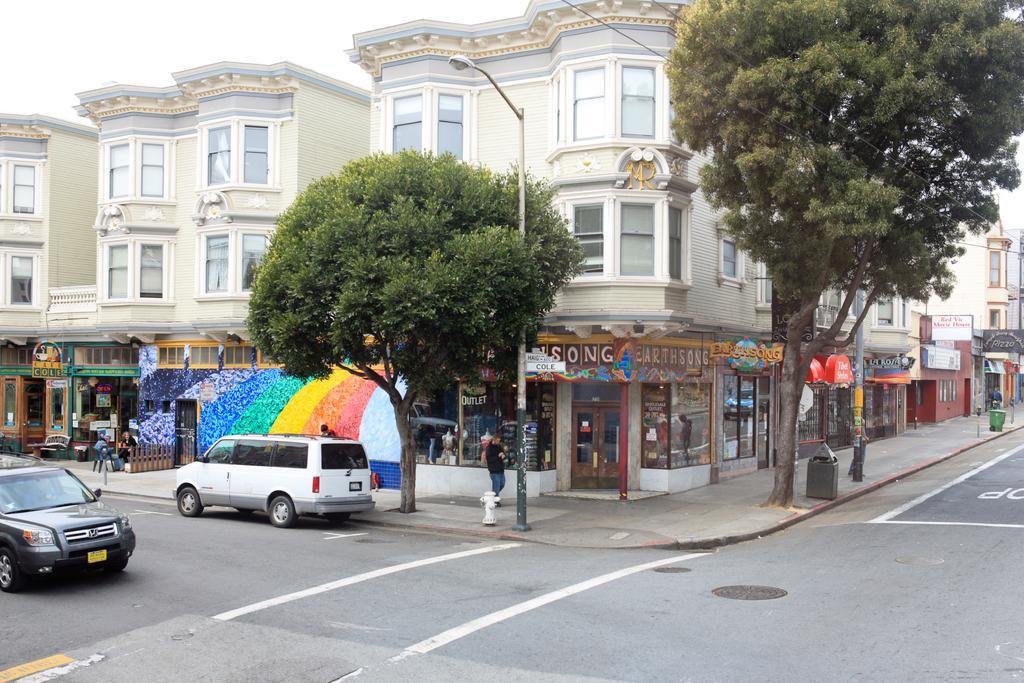How would you summarize this image in a sentence or two? This picture might be taken outside of the city. In this image, in the right side, we can see some buildings, windows, hoardings, trees and on the left side, we can see some cars are moving on the road. In the middle, we can see a man walking on the footpath, fire extinguisher, buildings, trees, street lights, electric wires. In the background, we can also see a building which is in cream color and windows. On top there is a sky, at the bottom, there is a road and footpath. 